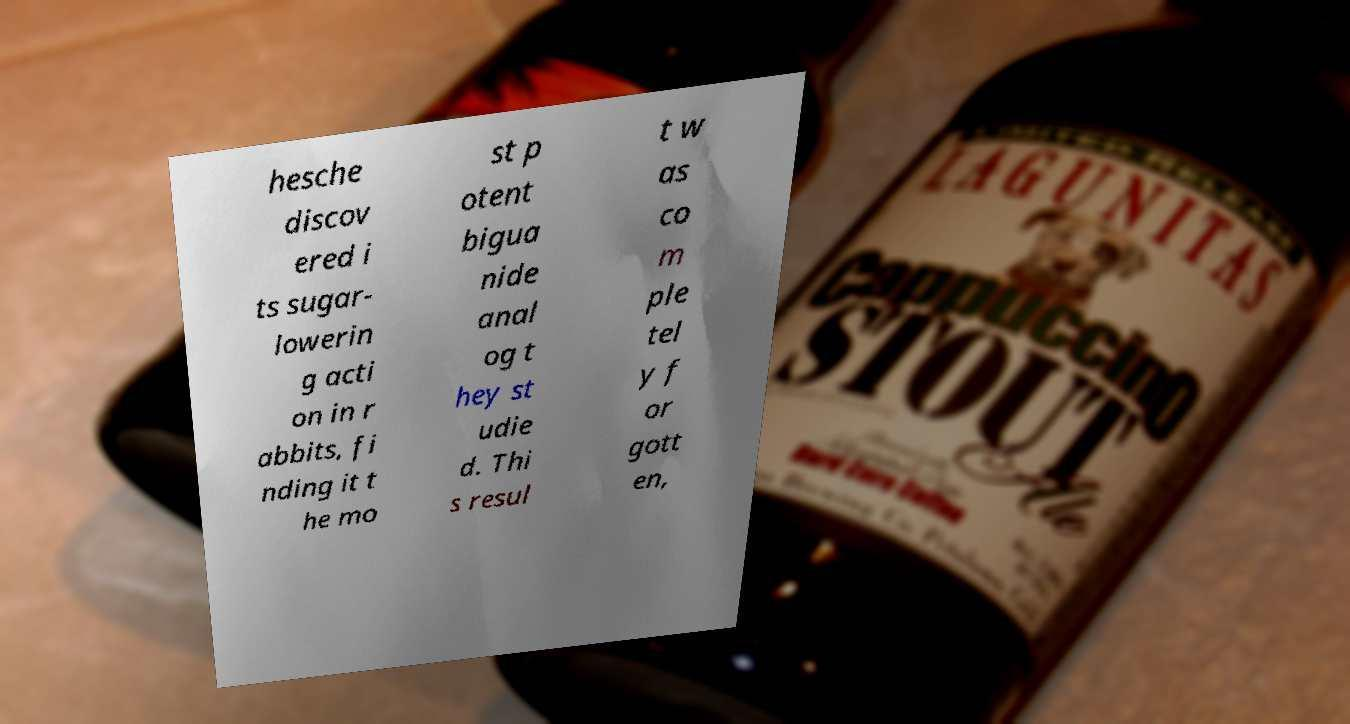Can you read and provide the text displayed in the image?This photo seems to have some interesting text. Can you extract and type it out for me? hesche discov ered i ts sugar- lowerin g acti on in r abbits, fi nding it t he mo st p otent bigua nide anal og t hey st udie d. Thi s resul t w as co m ple tel y f or gott en, 